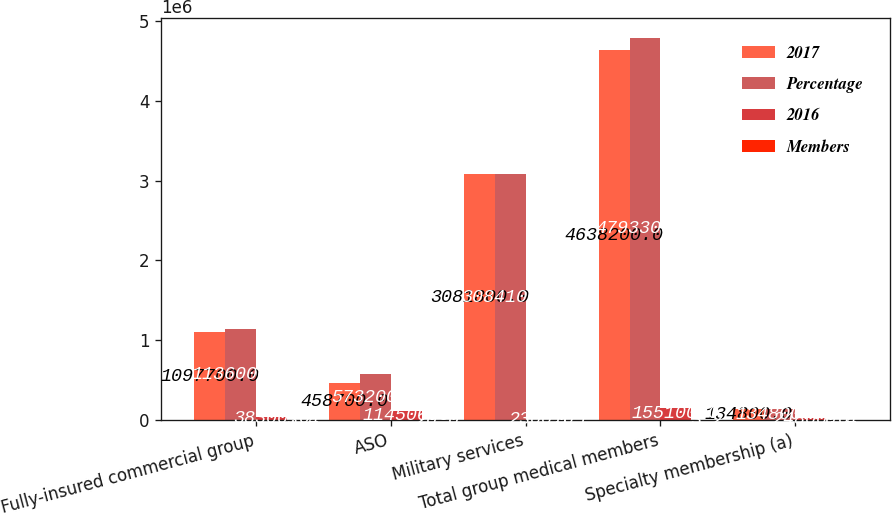Convert chart. <chart><loc_0><loc_0><loc_500><loc_500><stacked_bar_chart><ecel><fcel>Fully-insured commercial group<fcel>ASO<fcel>Military services<fcel>Total group medical members<fcel>Specialty membership (a)<nl><fcel>2017<fcel>1.0977e+06<fcel>458700<fcel>3.0818e+06<fcel>4.6382e+06<fcel>134800<nl><fcel>Percentage<fcel>1.136e+06<fcel>573200<fcel>3.0841e+06<fcel>4.7933e+06<fcel>134800<nl><fcel>2016<fcel>38300<fcel>114500<fcel>2300<fcel>155100<fcel>24800<nl><fcel>Members<fcel>3.4<fcel>20<fcel>0.1<fcel>3.2<fcel>0.4<nl></chart> 